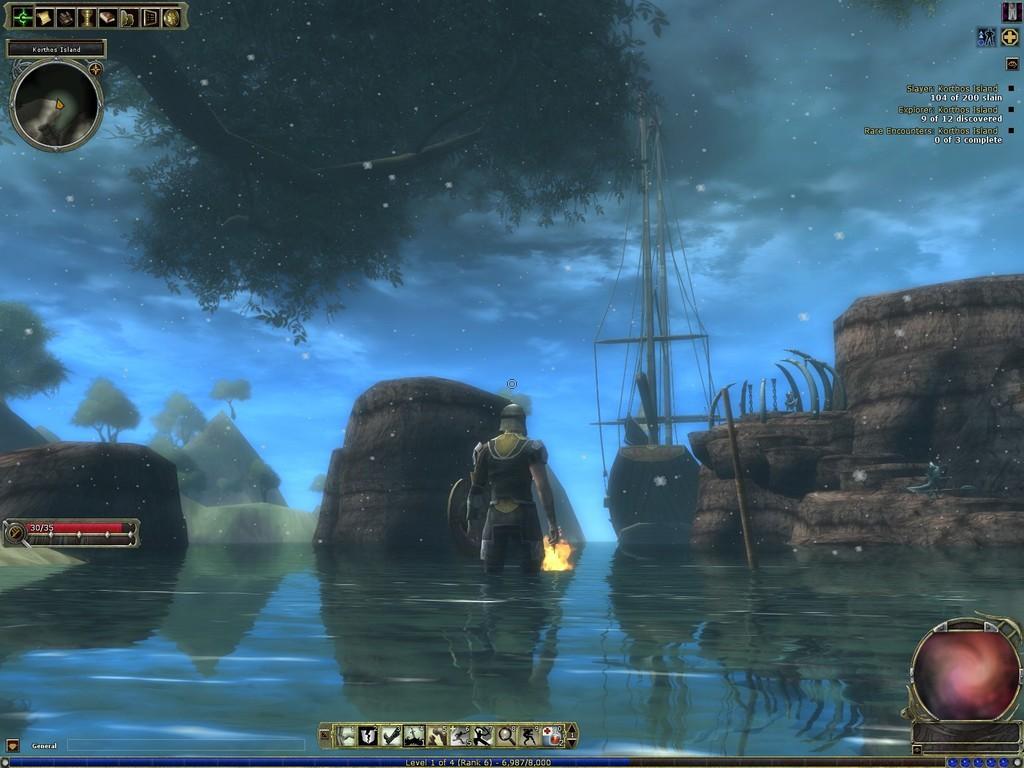In one or two sentences, can you explain what this image depicts? This is animated picture,there is a person's standing and we can see trees,stick,poles with strings and sky. 